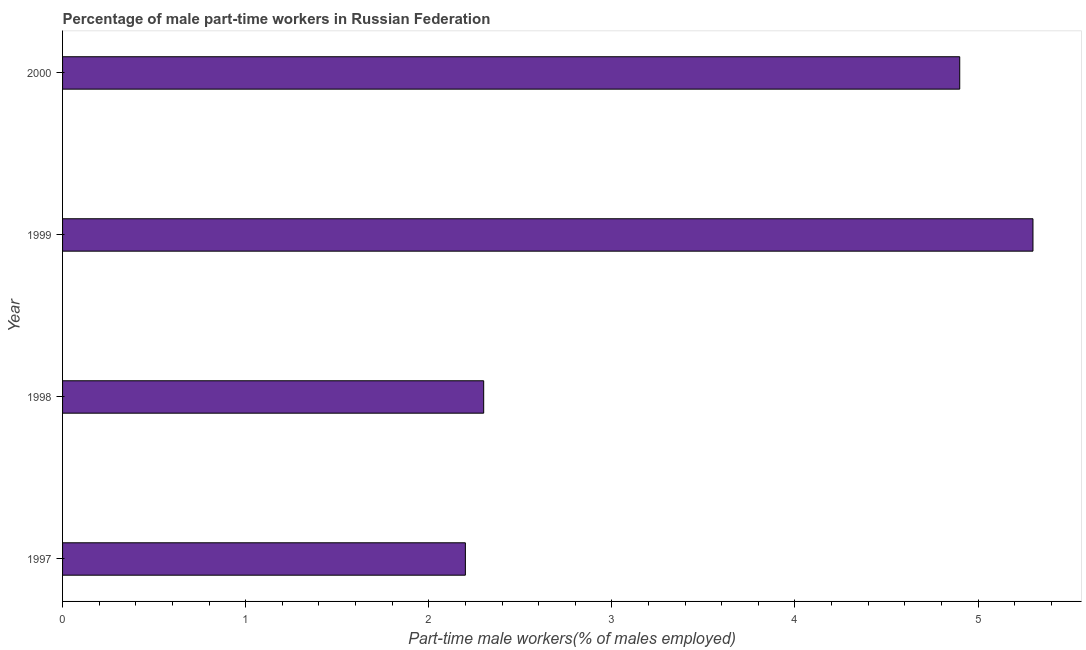Does the graph contain grids?
Keep it short and to the point. No. What is the title of the graph?
Offer a very short reply. Percentage of male part-time workers in Russian Federation. What is the label or title of the X-axis?
Offer a terse response. Part-time male workers(% of males employed). What is the label or title of the Y-axis?
Ensure brevity in your answer.  Year. What is the percentage of part-time male workers in 2000?
Your response must be concise. 4.9. Across all years, what is the maximum percentage of part-time male workers?
Provide a short and direct response. 5.3. Across all years, what is the minimum percentage of part-time male workers?
Offer a very short reply. 2.2. What is the sum of the percentage of part-time male workers?
Offer a very short reply. 14.7. What is the difference between the percentage of part-time male workers in 1997 and 2000?
Give a very brief answer. -2.7. What is the average percentage of part-time male workers per year?
Your answer should be compact. 3.67. What is the median percentage of part-time male workers?
Your answer should be compact. 3.6. In how many years, is the percentage of part-time male workers greater than 0.8 %?
Your response must be concise. 4. Do a majority of the years between 1998 and 2000 (inclusive) have percentage of part-time male workers greater than 5.2 %?
Provide a short and direct response. No. What is the difference between the highest and the lowest percentage of part-time male workers?
Provide a short and direct response. 3.1. How many bars are there?
Provide a short and direct response. 4. What is the difference between two consecutive major ticks on the X-axis?
Provide a short and direct response. 1. Are the values on the major ticks of X-axis written in scientific E-notation?
Provide a short and direct response. No. What is the Part-time male workers(% of males employed) of 1997?
Offer a terse response. 2.2. What is the Part-time male workers(% of males employed) of 1998?
Your response must be concise. 2.3. What is the Part-time male workers(% of males employed) of 1999?
Give a very brief answer. 5.3. What is the Part-time male workers(% of males employed) of 2000?
Give a very brief answer. 4.9. What is the difference between the Part-time male workers(% of males employed) in 1997 and 1998?
Provide a short and direct response. -0.1. What is the ratio of the Part-time male workers(% of males employed) in 1997 to that in 1998?
Provide a short and direct response. 0.96. What is the ratio of the Part-time male workers(% of males employed) in 1997 to that in 1999?
Offer a terse response. 0.41. What is the ratio of the Part-time male workers(% of males employed) in 1997 to that in 2000?
Your response must be concise. 0.45. What is the ratio of the Part-time male workers(% of males employed) in 1998 to that in 1999?
Ensure brevity in your answer.  0.43. What is the ratio of the Part-time male workers(% of males employed) in 1998 to that in 2000?
Provide a succinct answer. 0.47. What is the ratio of the Part-time male workers(% of males employed) in 1999 to that in 2000?
Ensure brevity in your answer.  1.08. 